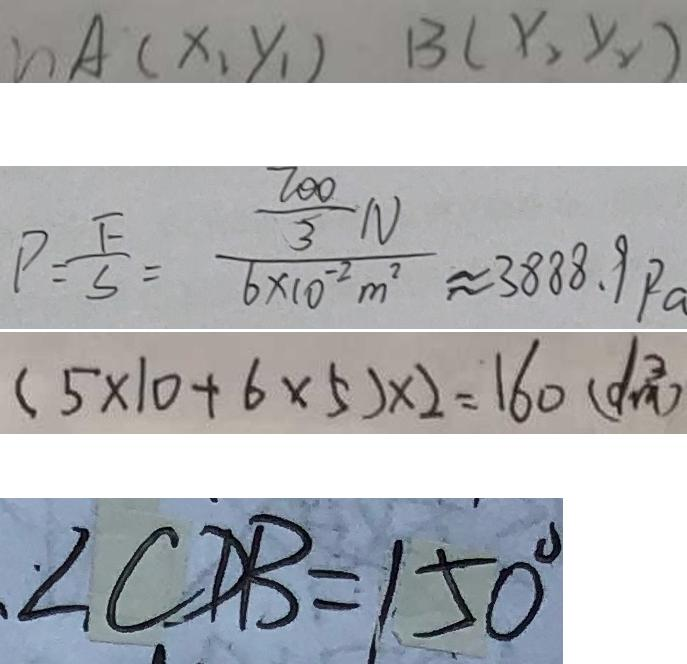Convert formula to latex. <formula><loc_0><loc_0><loc_500><loc_500>n A ( x _ { 1 } y _ { 1 } ) B ( x _ { 2 } y _ { 2 } ) 
 P = \frac { F } { S } = \frac { \frac { 7 0 0 } { 3 } N } { 6 \times 1 0 ^ { - 2 } m ^ { 2 } } \approx 3 8 8 8 . 9 P a 
 ( 5 \times 1 0 + 6 \times 5 ) \times 2 = 1 6 0 ( d m ^ { 3 } ) 
 \angle C D B = 1 5 0 ^ { \circ }</formula> 